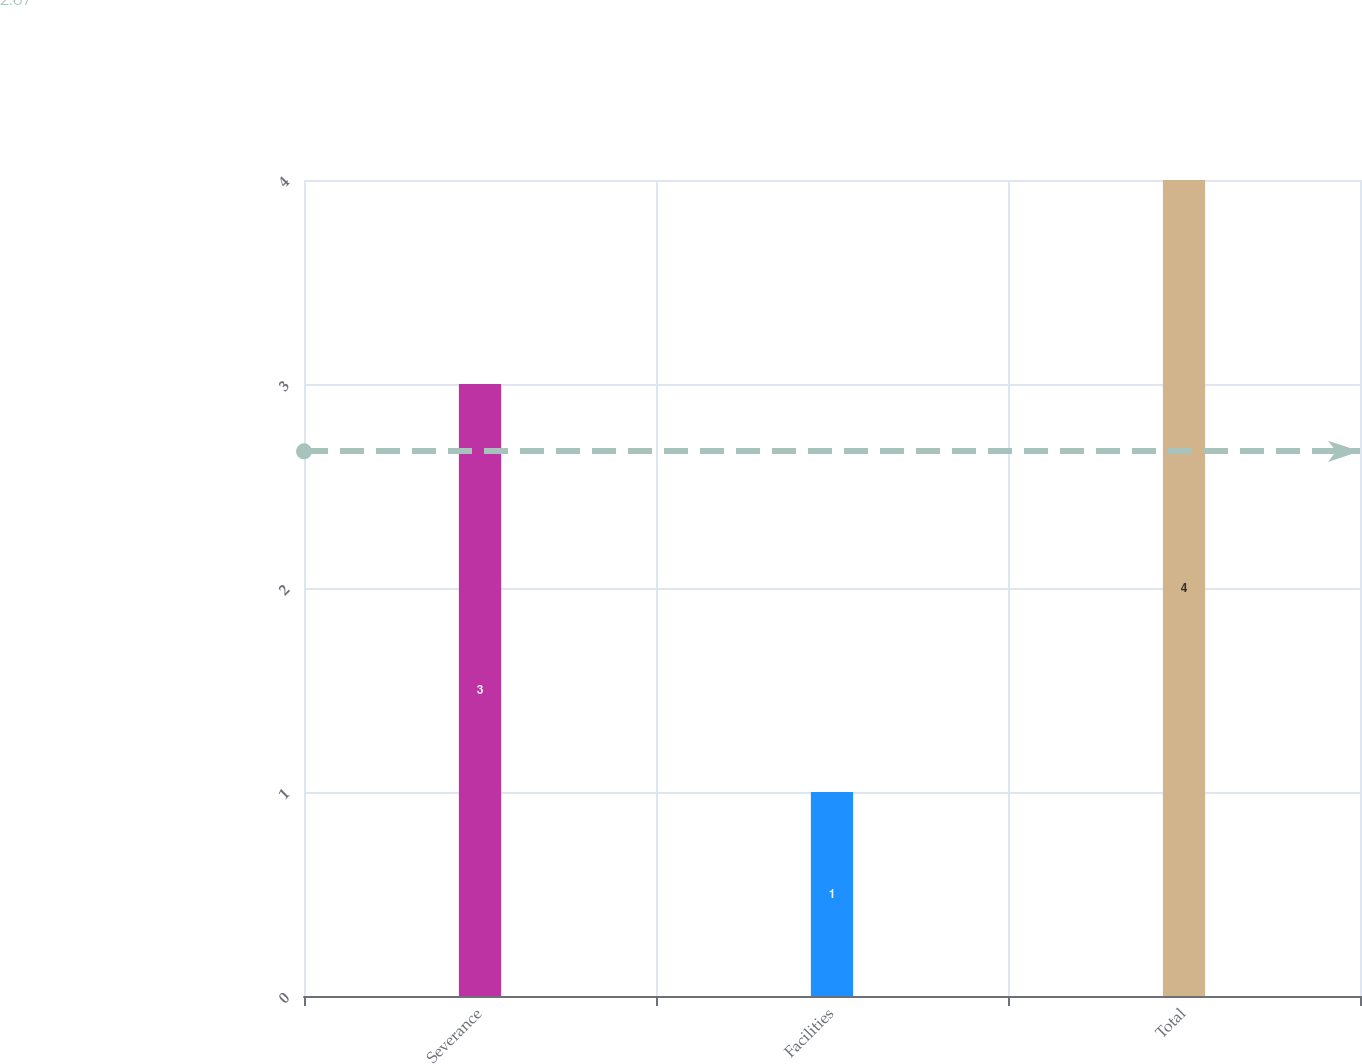Convert chart to OTSL. <chart><loc_0><loc_0><loc_500><loc_500><bar_chart><fcel>Severance<fcel>Facilities<fcel>Total<nl><fcel>3<fcel>1<fcel>4<nl></chart> 